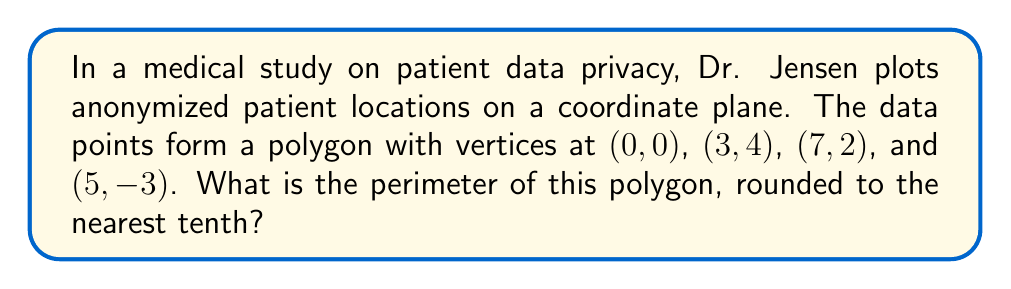Give your solution to this math problem. To find the perimeter of the polygon, we need to calculate the distances between consecutive vertices and sum them up. We'll use the distance formula between two points: $d = \sqrt{(x_2-x_1)^2 + (y_2-y_1)^2}$

1. Distance from (0, 0) to (3, 4):
   $d_1 = \sqrt{(3-0)^2 + (4-0)^2} = \sqrt{9 + 16} = \sqrt{25} = 5$

2. Distance from (3, 4) to (7, 2):
   $d_2 = \sqrt{(7-3)^2 + (2-4)^2} = \sqrt{16 + 4} = \sqrt{20} = 2\sqrt{5}$

3. Distance from (7, 2) to (5, -3):
   $d_3 = \sqrt{(5-7)^2 + (-3-2)^2} = \sqrt{4 + 25} = \sqrt{29}$

4. Distance from (5, -3) to (0, 0):
   $d_4 = \sqrt{(0-5)^2 + (0-(-3))^2} = \sqrt{25 + 9} = \sqrt{34}$

Now, we sum up all these distances:

$$\text{Perimeter} = 5 + 2\sqrt{5} + \sqrt{29} + \sqrt{34}$$

Using a calculator and rounding to the nearest tenth:

$$\text{Perimeter} \approx 5 + 4.5 + 5.4 + 5.8 = 20.7$$
Answer: 20.7 